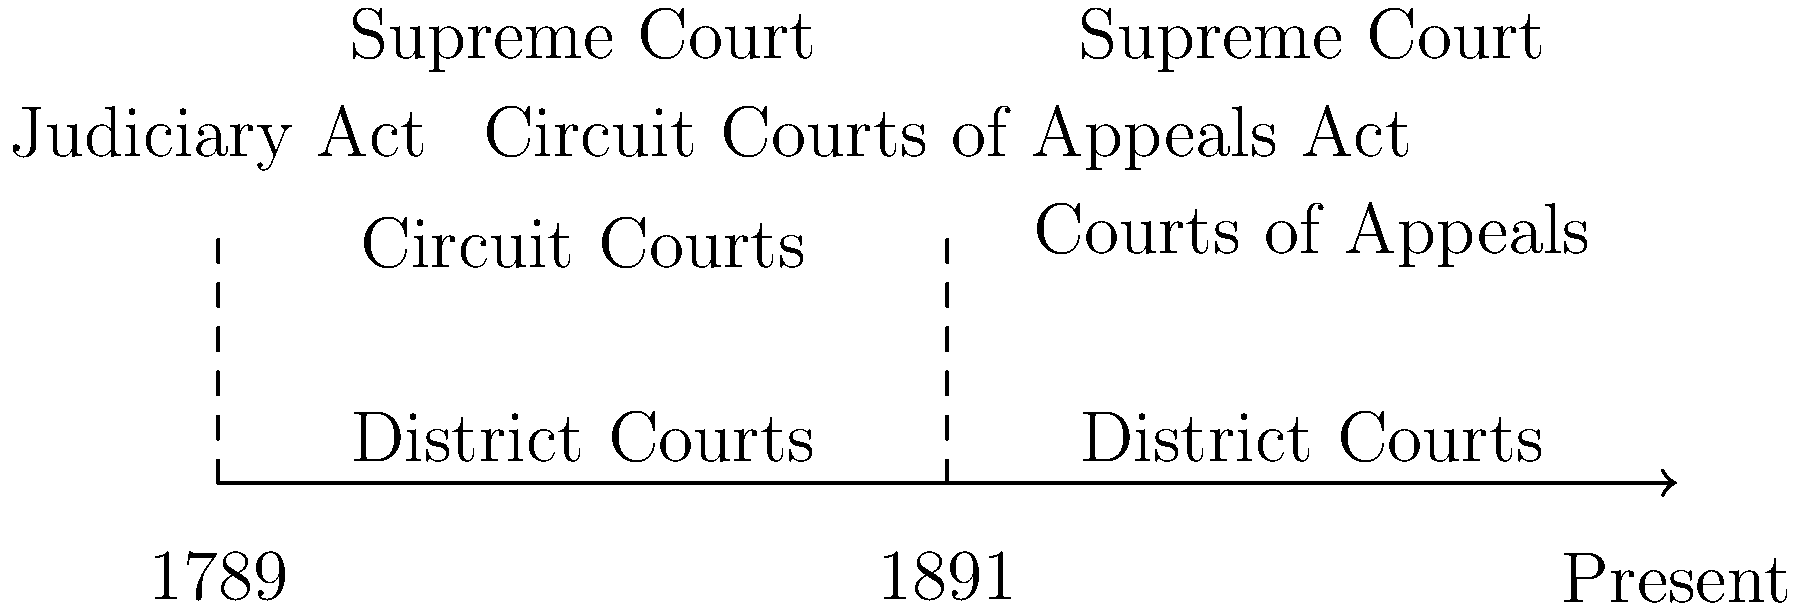Based on the timeline, which Act significantly restructured the federal court system by introducing a new level of appellate courts, and in what year was it implemented? To answer this question, let's analyze the timeline step-by-step:

1. The timeline shows two significant events in the evolution of the U.S. federal court system.

2. The first event occurs in 1789, labeled as the "Judiciary Act." This Act established the initial structure of the federal court system, including the Supreme Court, Circuit Courts, and District Courts.

3. The second event occurs in 1891, labeled as the "Circuit Courts of Appeals Act." This is the key piece of information for answering the question.

4. The Circuit Courts of Appeals Act of 1891 introduced a new level of appellate courts between the District Courts and the Supreme Court. This is evident from the change in the court structure shown on the right side of the timeline.

5. Before 1891, the federal court system had three levels: District Courts, Circuit Courts, and the Supreme Court.

6. After 1891, the system was restructured to have District Courts, Courts of Appeals (replacing the appellate function of Circuit Courts), and the Supreme Court.

7. This restructuring significantly altered the federal court system by creating a dedicated level of appellate courts, which helped to reduce the Supreme Court's caseload and improved the efficiency of the federal judiciary.

Therefore, the Act that significantly restructured the federal court system by introducing a new level of appellate courts was the Circuit Courts of Appeals Act, implemented in 1891.
Answer: Circuit Courts of Appeals Act, 1891 